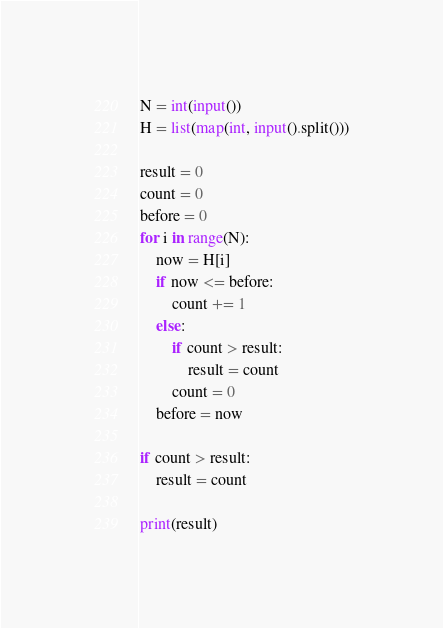<code> <loc_0><loc_0><loc_500><loc_500><_Python_>N = int(input())
H = list(map(int, input().split()))

result = 0
count = 0
before = 0
for i in range(N):
    now = H[i]
    if now <= before:
        count += 1
    else:
        if count > result:
            result = count
        count = 0
    before = now

if count > result:
    result = count

print(result)
</code> 